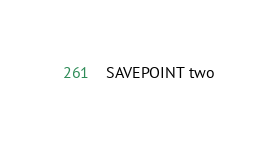Convert code to text. <code><loc_0><loc_0><loc_500><loc_500><_SQL_>SAVEPOINT two
</code> 